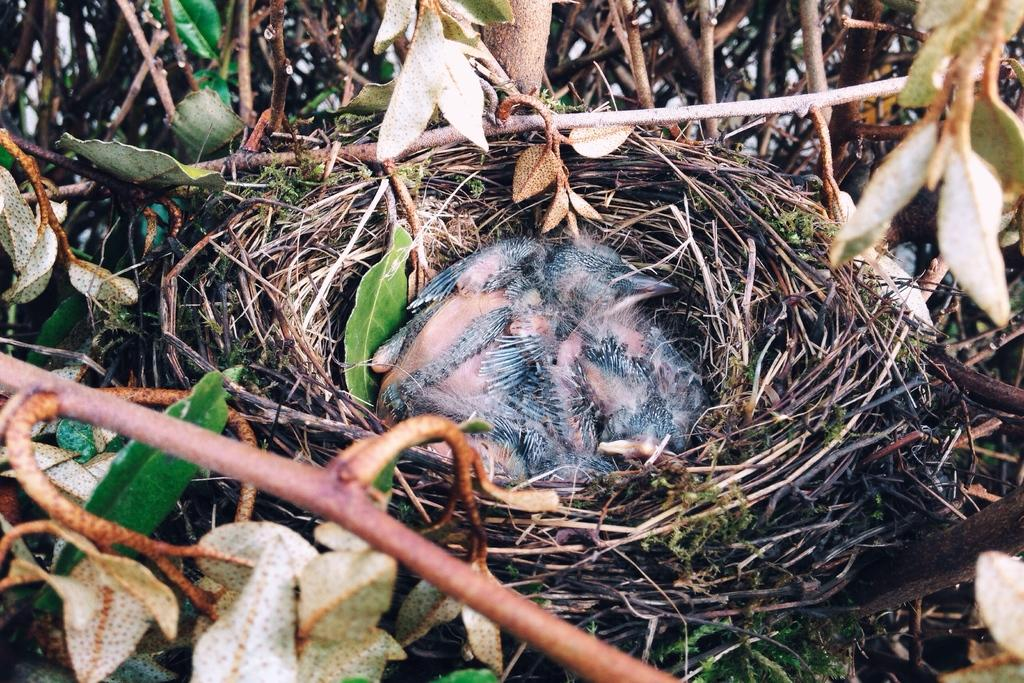What type of animal can be seen in the image? There is a bird in the image. Where is the bird located? The bird is in a nest. What can be seen in the background of the image? There is a tree visible in the background of the image. What type of jelly is being used to secure the bird's nest in the image? There is no jelly present in the image, and it is not mentioned that the bird's nest is secured with any substance. 